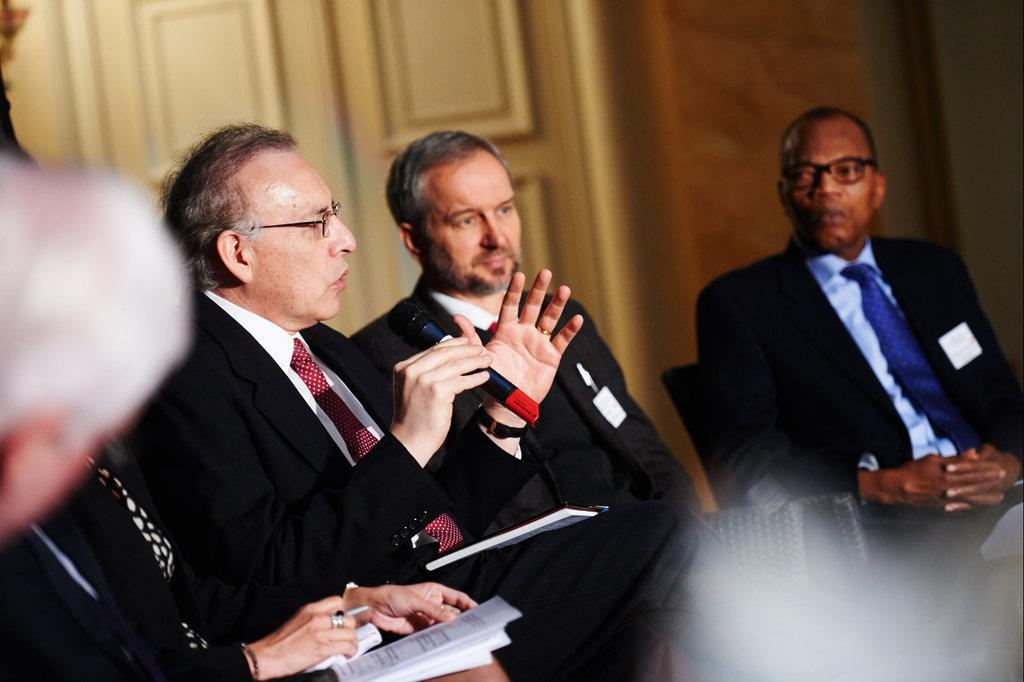What are the people in the image doing? The people in the image are sitting on chairs. What is the man holding in his hand? The man is holding a mic in his hand. What can be seen on the table or surface in front of the people? There are papers in the image. Can you describe the background of the image? There are doors and a wall visible in the background of the image. What type of cub can be seen playing with a pail in the image? There is no cub or pail present in the image; it features people sitting on chairs and a man holding a mic. What time of day is it in the image, considering the presence of an afternoon sun? There is no mention of the time of day or the presence of an afternoon sun in the image. 